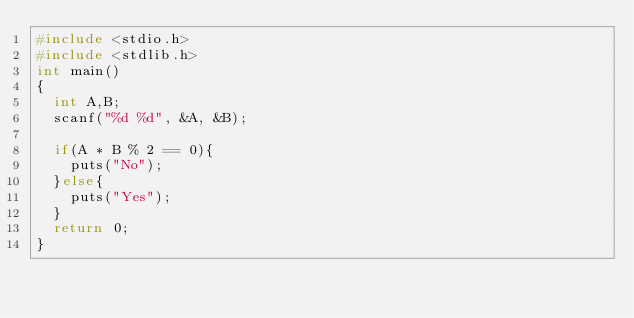Convert code to text. <code><loc_0><loc_0><loc_500><loc_500><_C_>#include <stdio.h>
#include <stdlib.h>
int main()
{
	int A,B;
	scanf("%d %d", &A, &B);
	
	if(A * B % 2 == 0){
		puts("No");
	}else{
		puts("Yes");
	}
	return 0;
}</code> 